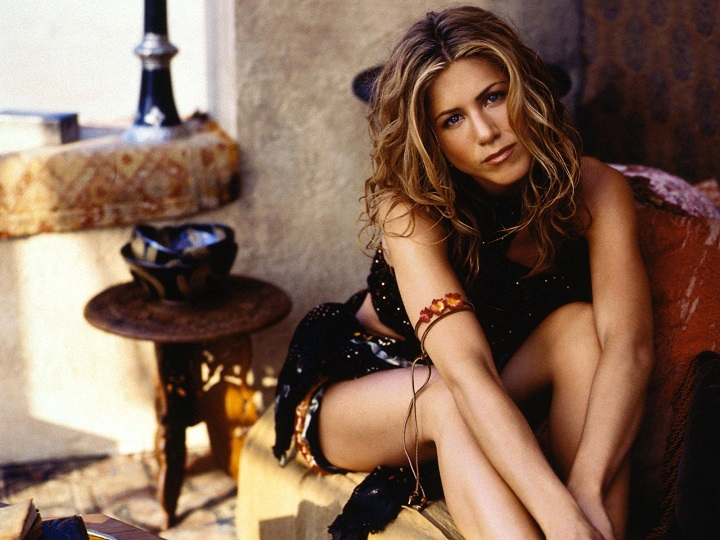What does the style of furniture and decor suggest about the geographical location where this photo might have been taken? The furniture and decor suggest a location with a warm climate, likely Mediterranean or similar. The rustic wooden table, patterned cushion, and stucco wall finish are characteristic of such regions. These elements, combined with the outdoor setting and stone flooring, evoke a casual, relaxed atmosphere often found in coastal areas of Southern Europe or places with a similar aesthetic. 